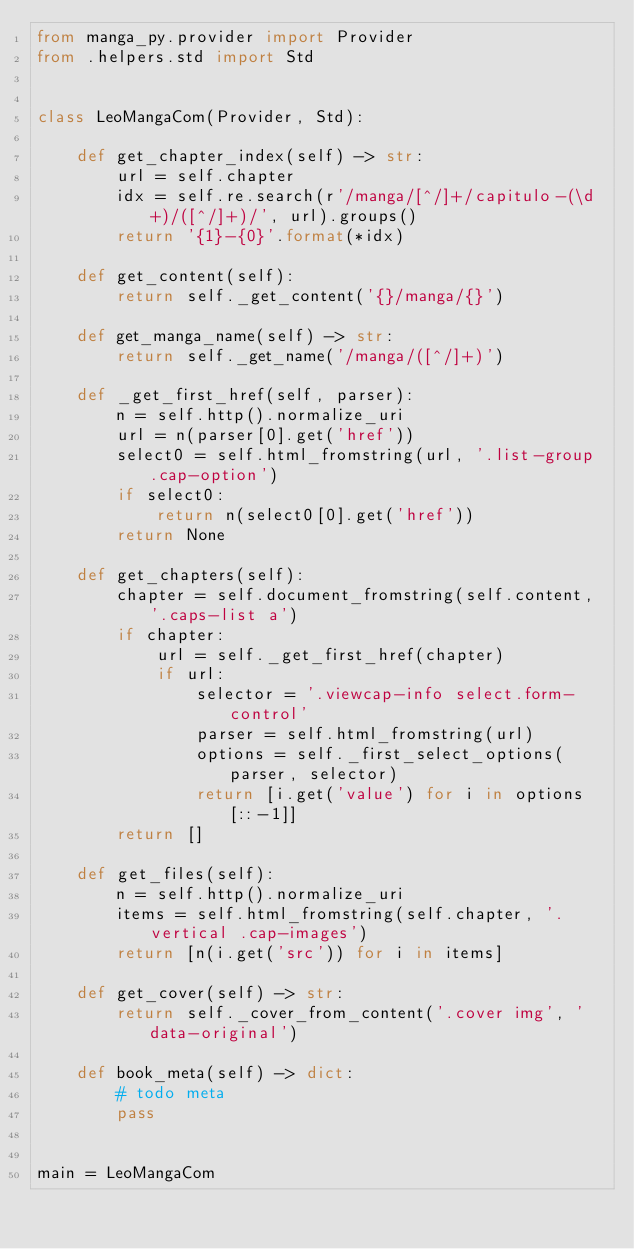<code> <loc_0><loc_0><loc_500><loc_500><_Python_>from manga_py.provider import Provider
from .helpers.std import Std


class LeoMangaCom(Provider, Std):

    def get_chapter_index(self) -> str:
        url = self.chapter
        idx = self.re.search(r'/manga/[^/]+/capitulo-(\d+)/([^/]+)/', url).groups()
        return '{1}-{0}'.format(*idx)

    def get_content(self):
        return self._get_content('{}/manga/{}')

    def get_manga_name(self) -> str:
        return self._get_name('/manga/([^/]+)')

    def _get_first_href(self, parser):
        n = self.http().normalize_uri
        url = n(parser[0].get('href'))
        select0 = self.html_fromstring(url, '.list-group .cap-option')
        if select0:
            return n(select0[0].get('href'))
        return None

    def get_chapters(self):
        chapter = self.document_fromstring(self.content, '.caps-list a')
        if chapter:
            url = self._get_first_href(chapter)
            if url:
                selector = '.viewcap-info select.form-control'
                parser = self.html_fromstring(url)
                options = self._first_select_options(parser, selector)
                return [i.get('value') for i in options[::-1]]
        return []

    def get_files(self):
        n = self.http().normalize_uri
        items = self.html_fromstring(self.chapter, '.vertical .cap-images')
        return [n(i.get('src')) for i in items]

    def get_cover(self) -> str:
        return self._cover_from_content('.cover img', 'data-original')

    def book_meta(self) -> dict:
        # todo meta
        pass


main = LeoMangaCom
</code> 